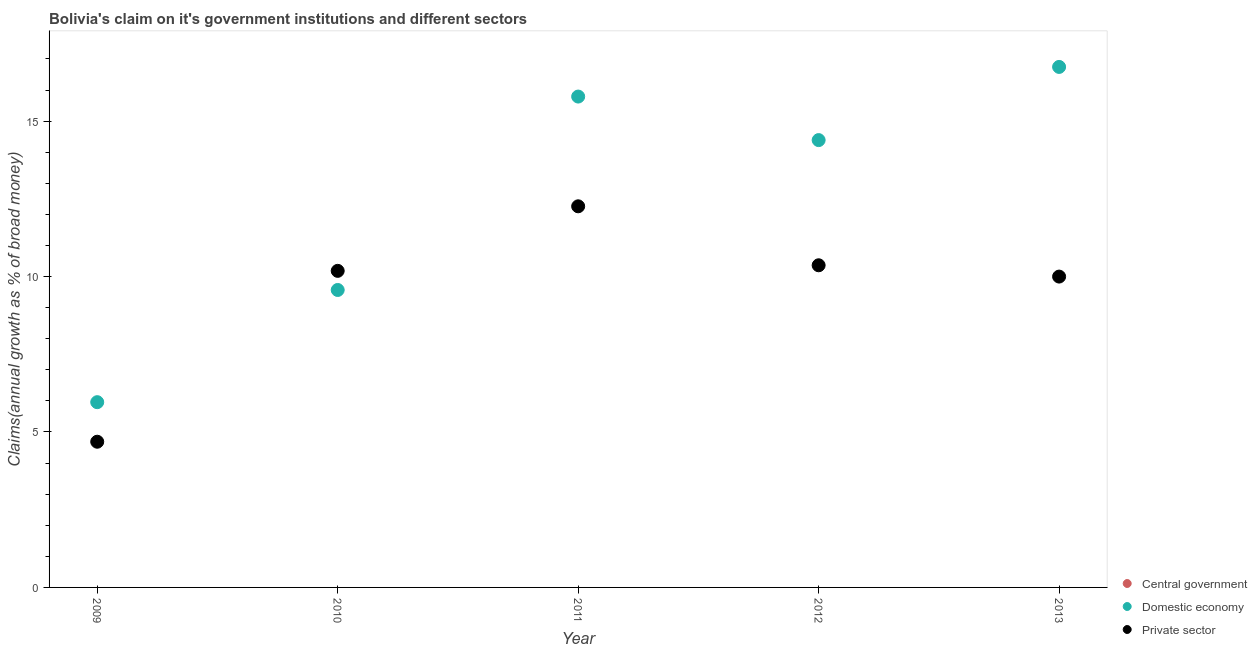How many different coloured dotlines are there?
Provide a short and direct response. 2. What is the percentage of claim on the domestic economy in 2010?
Your answer should be compact. 9.57. Across all years, what is the maximum percentage of claim on the domestic economy?
Ensure brevity in your answer.  16.74. Across all years, what is the minimum percentage of claim on the private sector?
Provide a succinct answer. 4.69. In which year was the percentage of claim on the private sector maximum?
Ensure brevity in your answer.  2011. What is the total percentage of claim on the private sector in the graph?
Your answer should be compact. 47.49. What is the difference between the percentage of claim on the private sector in 2009 and that in 2010?
Ensure brevity in your answer.  -5.5. What is the difference between the percentage of claim on the central government in 2010 and the percentage of claim on the domestic economy in 2012?
Ensure brevity in your answer.  -14.39. What is the average percentage of claim on the domestic economy per year?
Give a very brief answer. 12.49. In the year 2011, what is the difference between the percentage of claim on the private sector and percentage of claim on the domestic economy?
Your answer should be compact. -3.53. In how many years, is the percentage of claim on the domestic economy greater than 12 %?
Make the answer very short. 3. What is the ratio of the percentage of claim on the domestic economy in 2009 to that in 2010?
Make the answer very short. 0.62. Is the percentage of claim on the domestic economy in 2010 less than that in 2013?
Give a very brief answer. Yes. What is the difference between the highest and the second highest percentage of claim on the domestic economy?
Offer a terse response. 0.95. What is the difference between the highest and the lowest percentage of claim on the private sector?
Give a very brief answer. 7.57. In how many years, is the percentage of claim on the central government greater than the average percentage of claim on the central government taken over all years?
Your response must be concise. 0. Is it the case that in every year, the sum of the percentage of claim on the central government and percentage of claim on the domestic economy is greater than the percentage of claim on the private sector?
Give a very brief answer. No. Is the percentage of claim on the domestic economy strictly less than the percentage of claim on the private sector over the years?
Provide a short and direct response. No. How many years are there in the graph?
Keep it short and to the point. 5. What is the difference between two consecutive major ticks on the Y-axis?
Your response must be concise. 5. Are the values on the major ticks of Y-axis written in scientific E-notation?
Ensure brevity in your answer.  No. Does the graph contain grids?
Your answer should be compact. No. Where does the legend appear in the graph?
Provide a short and direct response. Bottom right. How many legend labels are there?
Keep it short and to the point. 3. What is the title of the graph?
Keep it short and to the point. Bolivia's claim on it's government institutions and different sectors. What is the label or title of the X-axis?
Your answer should be compact. Year. What is the label or title of the Y-axis?
Provide a short and direct response. Claims(annual growth as % of broad money). What is the Claims(annual growth as % of broad money) of Central government in 2009?
Ensure brevity in your answer.  0. What is the Claims(annual growth as % of broad money) in Domestic economy in 2009?
Make the answer very short. 5.96. What is the Claims(annual growth as % of broad money) in Private sector in 2009?
Provide a succinct answer. 4.69. What is the Claims(annual growth as % of broad money) of Domestic economy in 2010?
Provide a succinct answer. 9.57. What is the Claims(annual growth as % of broad money) in Private sector in 2010?
Provide a succinct answer. 10.18. What is the Claims(annual growth as % of broad money) in Central government in 2011?
Ensure brevity in your answer.  0. What is the Claims(annual growth as % of broad money) in Domestic economy in 2011?
Make the answer very short. 15.79. What is the Claims(annual growth as % of broad money) of Private sector in 2011?
Ensure brevity in your answer.  12.26. What is the Claims(annual growth as % of broad money) of Central government in 2012?
Give a very brief answer. 0. What is the Claims(annual growth as % of broad money) in Domestic economy in 2012?
Offer a very short reply. 14.39. What is the Claims(annual growth as % of broad money) in Private sector in 2012?
Your response must be concise. 10.36. What is the Claims(annual growth as % of broad money) in Domestic economy in 2013?
Your answer should be compact. 16.74. What is the Claims(annual growth as % of broad money) in Private sector in 2013?
Provide a short and direct response. 10. Across all years, what is the maximum Claims(annual growth as % of broad money) in Domestic economy?
Your answer should be compact. 16.74. Across all years, what is the maximum Claims(annual growth as % of broad money) in Private sector?
Your response must be concise. 12.26. Across all years, what is the minimum Claims(annual growth as % of broad money) of Domestic economy?
Keep it short and to the point. 5.96. Across all years, what is the minimum Claims(annual growth as % of broad money) of Private sector?
Give a very brief answer. 4.69. What is the total Claims(annual growth as % of broad money) in Domestic economy in the graph?
Give a very brief answer. 62.45. What is the total Claims(annual growth as % of broad money) of Private sector in the graph?
Keep it short and to the point. 47.49. What is the difference between the Claims(annual growth as % of broad money) in Domestic economy in 2009 and that in 2010?
Offer a very short reply. -3.61. What is the difference between the Claims(annual growth as % of broad money) of Private sector in 2009 and that in 2010?
Make the answer very short. -5.5. What is the difference between the Claims(annual growth as % of broad money) of Domestic economy in 2009 and that in 2011?
Provide a short and direct response. -9.83. What is the difference between the Claims(annual growth as % of broad money) in Private sector in 2009 and that in 2011?
Ensure brevity in your answer.  -7.57. What is the difference between the Claims(annual growth as % of broad money) in Domestic economy in 2009 and that in 2012?
Offer a very short reply. -8.43. What is the difference between the Claims(annual growth as % of broad money) of Private sector in 2009 and that in 2012?
Offer a very short reply. -5.68. What is the difference between the Claims(annual growth as % of broad money) of Domestic economy in 2009 and that in 2013?
Keep it short and to the point. -10.78. What is the difference between the Claims(annual growth as % of broad money) of Private sector in 2009 and that in 2013?
Your answer should be very brief. -5.31. What is the difference between the Claims(annual growth as % of broad money) of Domestic economy in 2010 and that in 2011?
Provide a short and direct response. -6.22. What is the difference between the Claims(annual growth as % of broad money) in Private sector in 2010 and that in 2011?
Your response must be concise. -2.08. What is the difference between the Claims(annual growth as % of broad money) in Domestic economy in 2010 and that in 2012?
Ensure brevity in your answer.  -4.82. What is the difference between the Claims(annual growth as % of broad money) in Private sector in 2010 and that in 2012?
Offer a very short reply. -0.18. What is the difference between the Claims(annual growth as % of broad money) in Domestic economy in 2010 and that in 2013?
Your answer should be very brief. -7.17. What is the difference between the Claims(annual growth as % of broad money) of Private sector in 2010 and that in 2013?
Your answer should be very brief. 0.18. What is the difference between the Claims(annual growth as % of broad money) of Domestic economy in 2011 and that in 2012?
Provide a short and direct response. 1.4. What is the difference between the Claims(annual growth as % of broad money) of Private sector in 2011 and that in 2012?
Make the answer very short. 1.9. What is the difference between the Claims(annual growth as % of broad money) in Domestic economy in 2011 and that in 2013?
Keep it short and to the point. -0.95. What is the difference between the Claims(annual growth as % of broad money) in Private sector in 2011 and that in 2013?
Your answer should be very brief. 2.26. What is the difference between the Claims(annual growth as % of broad money) in Domestic economy in 2012 and that in 2013?
Keep it short and to the point. -2.35. What is the difference between the Claims(annual growth as % of broad money) in Private sector in 2012 and that in 2013?
Keep it short and to the point. 0.36. What is the difference between the Claims(annual growth as % of broad money) in Domestic economy in 2009 and the Claims(annual growth as % of broad money) in Private sector in 2010?
Your response must be concise. -4.22. What is the difference between the Claims(annual growth as % of broad money) of Domestic economy in 2009 and the Claims(annual growth as % of broad money) of Private sector in 2011?
Keep it short and to the point. -6.3. What is the difference between the Claims(annual growth as % of broad money) of Domestic economy in 2009 and the Claims(annual growth as % of broad money) of Private sector in 2012?
Provide a succinct answer. -4.4. What is the difference between the Claims(annual growth as % of broad money) of Domestic economy in 2009 and the Claims(annual growth as % of broad money) of Private sector in 2013?
Your answer should be very brief. -4.04. What is the difference between the Claims(annual growth as % of broad money) of Domestic economy in 2010 and the Claims(annual growth as % of broad money) of Private sector in 2011?
Make the answer very short. -2.69. What is the difference between the Claims(annual growth as % of broad money) in Domestic economy in 2010 and the Claims(annual growth as % of broad money) in Private sector in 2012?
Ensure brevity in your answer.  -0.79. What is the difference between the Claims(annual growth as % of broad money) in Domestic economy in 2010 and the Claims(annual growth as % of broad money) in Private sector in 2013?
Provide a short and direct response. -0.43. What is the difference between the Claims(annual growth as % of broad money) of Domestic economy in 2011 and the Claims(annual growth as % of broad money) of Private sector in 2012?
Your response must be concise. 5.43. What is the difference between the Claims(annual growth as % of broad money) of Domestic economy in 2011 and the Claims(annual growth as % of broad money) of Private sector in 2013?
Give a very brief answer. 5.79. What is the difference between the Claims(annual growth as % of broad money) of Domestic economy in 2012 and the Claims(annual growth as % of broad money) of Private sector in 2013?
Give a very brief answer. 4.39. What is the average Claims(annual growth as % of broad money) in Domestic economy per year?
Provide a succinct answer. 12.49. What is the average Claims(annual growth as % of broad money) in Private sector per year?
Your response must be concise. 9.5. In the year 2009, what is the difference between the Claims(annual growth as % of broad money) in Domestic economy and Claims(annual growth as % of broad money) in Private sector?
Provide a short and direct response. 1.27. In the year 2010, what is the difference between the Claims(annual growth as % of broad money) of Domestic economy and Claims(annual growth as % of broad money) of Private sector?
Your answer should be very brief. -0.62. In the year 2011, what is the difference between the Claims(annual growth as % of broad money) in Domestic economy and Claims(annual growth as % of broad money) in Private sector?
Provide a succinct answer. 3.53. In the year 2012, what is the difference between the Claims(annual growth as % of broad money) in Domestic economy and Claims(annual growth as % of broad money) in Private sector?
Your answer should be compact. 4.03. In the year 2013, what is the difference between the Claims(annual growth as % of broad money) in Domestic economy and Claims(annual growth as % of broad money) in Private sector?
Keep it short and to the point. 6.74. What is the ratio of the Claims(annual growth as % of broad money) in Domestic economy in 2009 to that in 2010?
Ensure brevity in your answer.  0.62. What is the ratio of the Claims(annual growth as % of broad money) in Private sector in 2009 to that in 2010?
Your answer should be very brief. 0.46. What is the ratio of the Claims(annual growth as % of broad money) in Domestic economy in 2009 to that in 2011?
Provide a short and direct response. 0.38. What is the ratio of the Claims(annual growth as % of broad money) of Private sector in 2009 to that in 2011?
Offer a terse response. 0.38. What is the ratio of the Claims(annual growth as % of broad money) in Domestic economy in 2009 to that in 2012?
Give a very brief answer. 0.41. What is the ratio of the Claims(annual growth as % of broad money) in Private sector in 2009 to that in 2012?
Provide a succinct answer. 0.45. What is the ratio of the Claims(annual growth as % of broad money) in Domestic economy in 2009 to that in 2013?
Provide a succinct answer. 0.36. What is the ratio of the Claims(annual growth as % of broad money) in Private sector in 2009 to that in 2013?
Offer a terse response. 0.47. What is the ratio of the Claims(annual growth as % of broad money) of Domestic economy in 2010 to that in 2011?
Offer a very short reply. 0.61. What is the ratio of the Claims(annual growth as % of broad money) of Private sector in 2010 to that in 2011?
Your answer should be compact. 0.83. What is the ratio of the Claims(annual growth as % of broad money) in Domestic economy in 2010 to that in 2012?
Keep it short and to the point. 0.66. What is the ratio of the Claims(annual growth as % of broad money) of Private sector in 2010 to that in 2012?
Provide a short and direct response. 0.98. What is the ratio of the Claims(annual growth as % of broad money) in Domestic economy in 2010 to that in 2013?
Offer a terse response. 0.57. What is the ratio of the Claims(annual growth as % of broad money) in Private sector in 2010 to that in 2013?
Give a very brief answer. 1.02. What is the ratio of the Claims(annual growth as % of broad money) of Domestic economy in 2011 to that in 2012?
Provide a succinct answer. 1.1. What is the ratio of the Claims(annual growth as % of broad money) of Private sector in 2011 to that in 2012?
Provide a short and direct response. 1.18. What is the ratio of the Claims(annual growth as % of broad money) of Domestic economy in 2011 to that in 2013?
Make the answer very short. 0.94. What is the ratio of the Claims(annual growth as % of broad money) in Private sector in 2011 to that in 2013?
Your response must be concise. 1.23. What is the ratio of the Claims(annual growth as % of broad money) of Domestic economy in 2012 to that in 2013?
Your answer should be compact. 0.86. What is the ratio of the Claims(annual growth as % of broad money) in Private sector in 2012 to that in 2013?
Provide a short and direct response. 1.04. What is the difference between the highest and the second highest Claims(annual growth as % of broad money) of Domestic economy?
Offer a very short reply. 0.95. What is the difference between the highest and the second highest Claims(annual growth as % of broad money) of Private sector?
Provide a succinct answer. 1.9. What is the difference between the highest and the lowest Claims(annual growth as % of broad money) of Domestic economy?
Ensure brevity in your answer.  10.78. What is the difference between the highest and the lowest Claims(annual growth as % of broad money) of Private sector?
Keep it short and to the point. 7.57. 